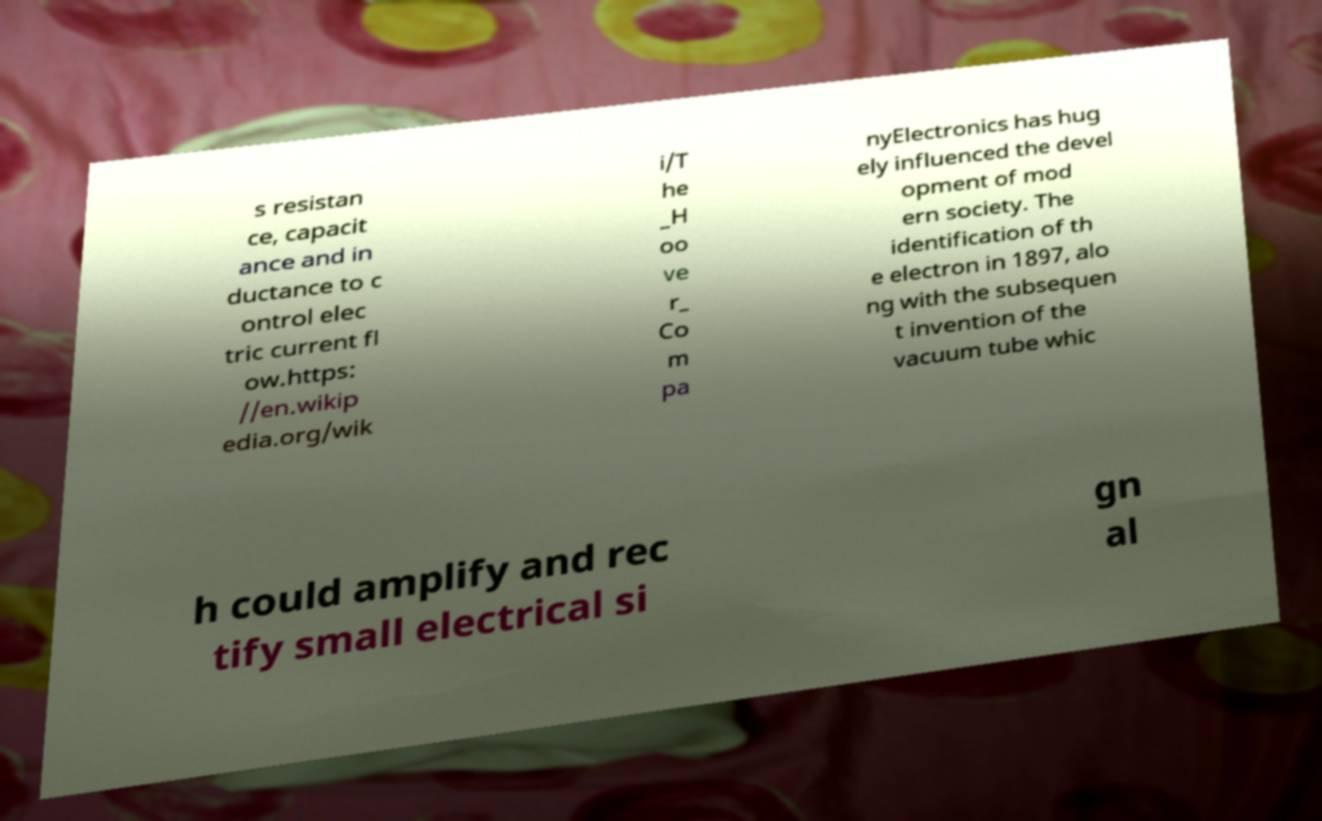Please identify and transcribe the text found in this image. s resistan ce, capacit ance and in ductance to c ontrol elec tric current fl ow.https: //en.wikip edia.org/wik i/T he _H oo ve r_ Co m pa nyElectronics has hug ely influenced the devel opment of mod ern society. The identification of th e electron in 1897, alo ng with the subsequen t invention of the vacuum tube whic h could amplify and rec tify small electrical si gn al 